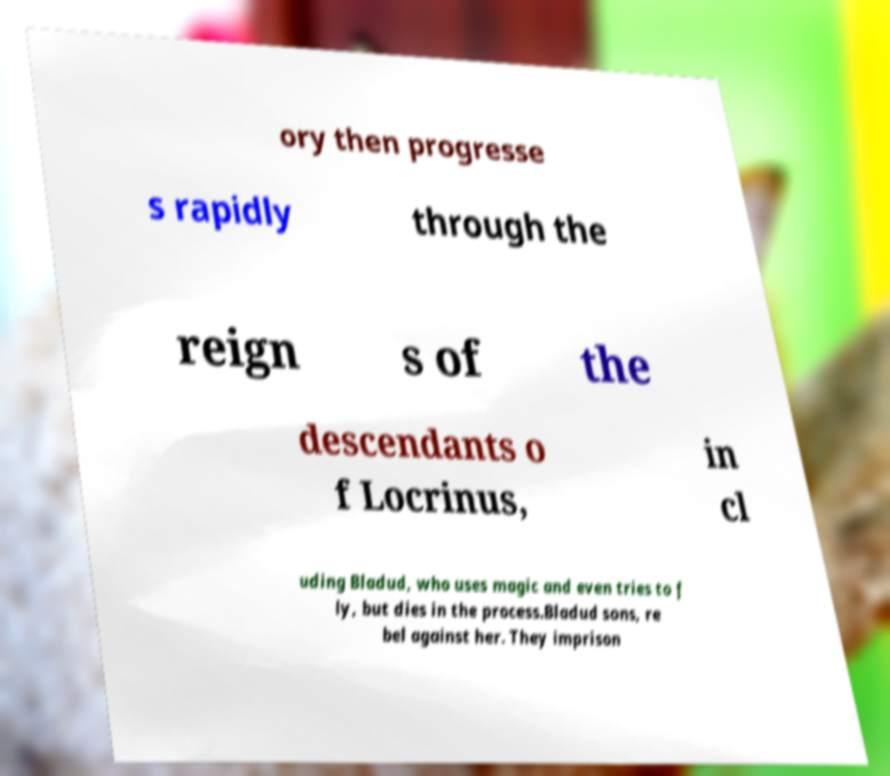Can you accurately transcribe the text from the provided image for me? ory then progresse s rapidly through the reign s of the descendants o f Locrinus, in cl uding Bladud, who uses magic and even tries to f ly, but dies in the process.Bladud sons, re bel against her. They imprison 